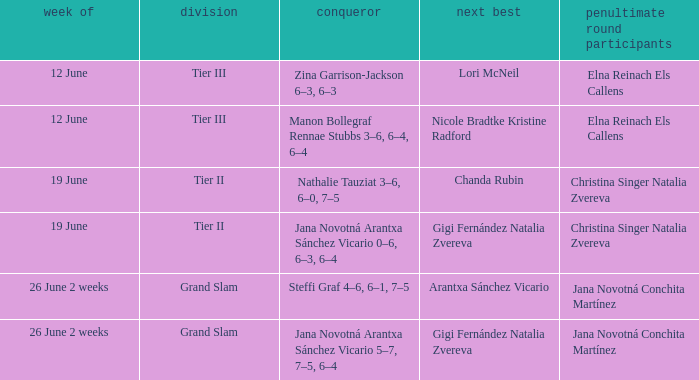Who claimed victory in the week listed as 26 june 2 weeks, when the person finishing just behind was arantxa sánchez vicario? Steffi Graf 4–6, 6–1, 7–5. 